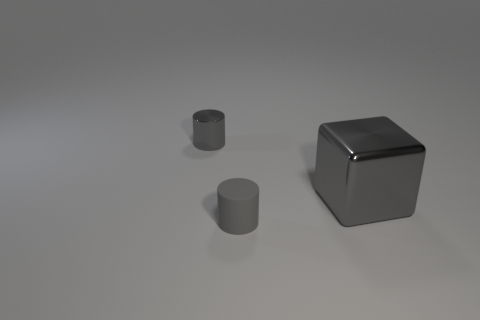Can you describe the lighting in the image? The image features soft, diffused lighting with the light source seemingly located above the objects, as indicated by the highlights and gentle shadows they cast upon the plane. 